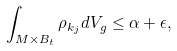Convert formula to latex. <formula><loc_0><loc_0><loc_500><loc_500>\int _ { M \times B _ { t } } \rho _ { k _ { j } } d V _ { g } \leq \alpha + \epsilon ,</formula> 